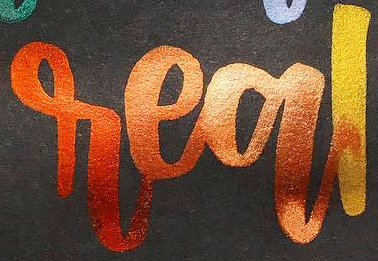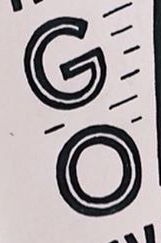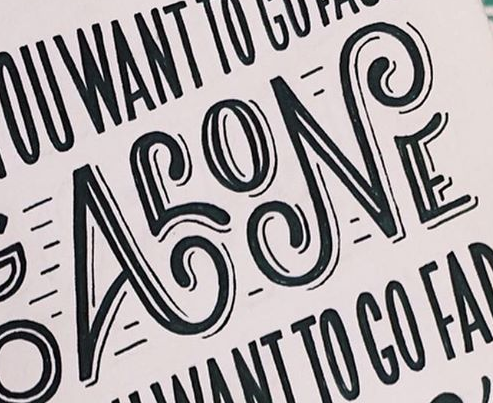What words are shown in these images in order, separated by a semicolon? real; GO; ALONE 